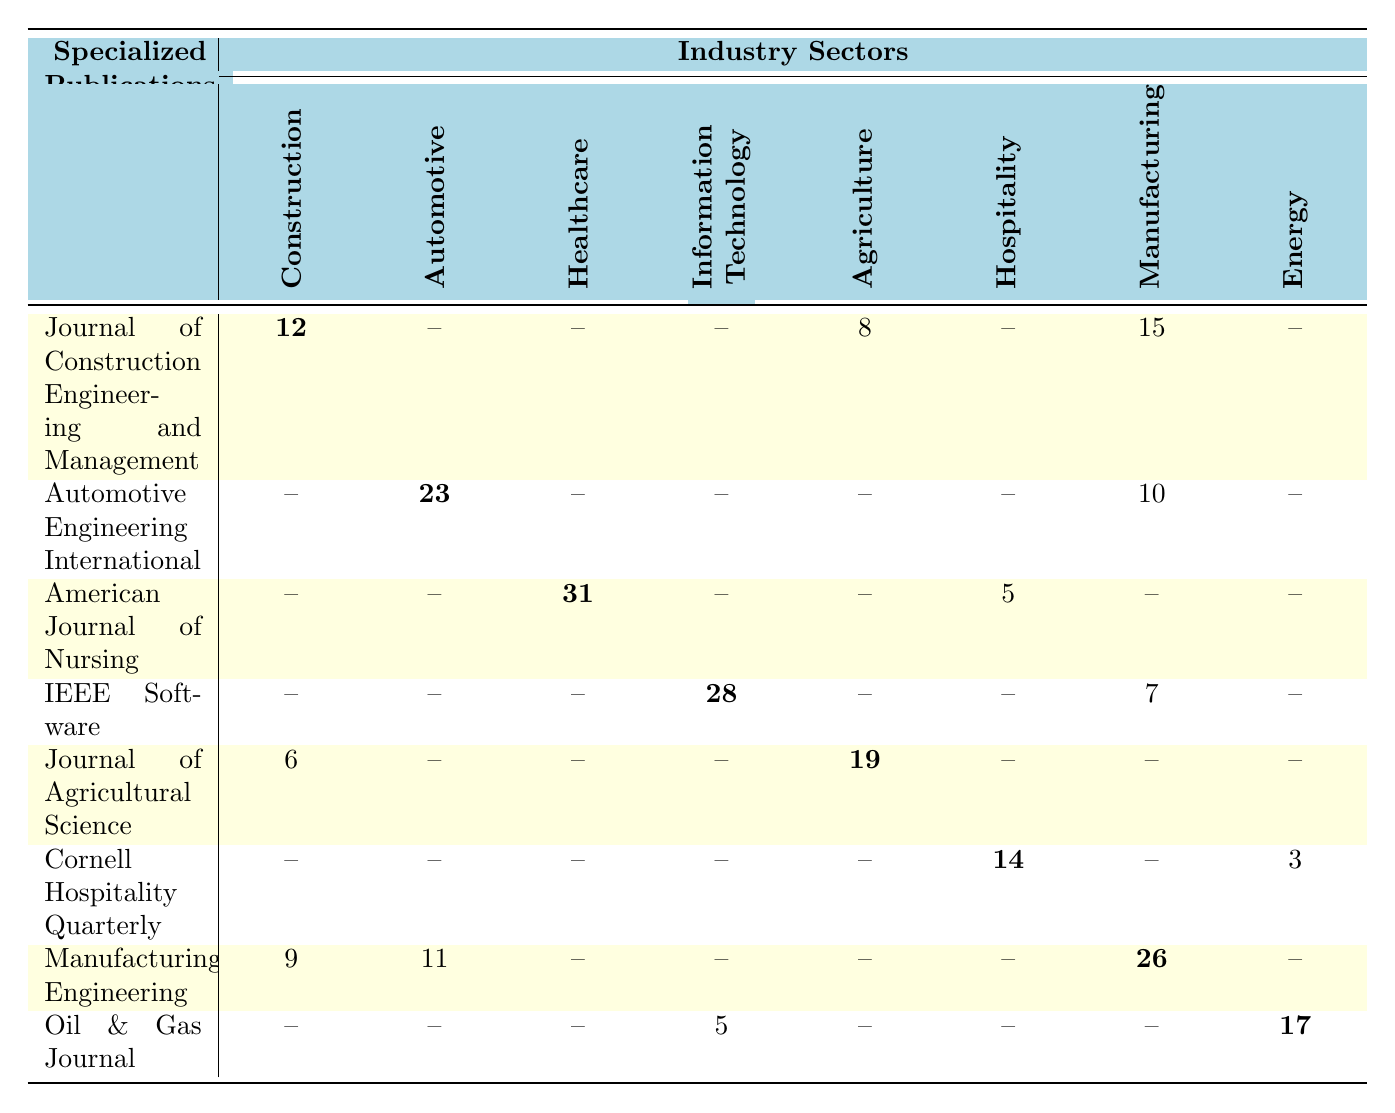What is the total number of interlibrary loan requests for the "American Journal of Nursing"? The table shows that the "American Journal of Nursing" has 31 requests from the Healthcare sector and 5 requests from the Hospitality sector. To find the total, we sum these two values: 31 + 5 = 36.
Answer: 36 Which specialized publication received the highest number of interlibrary loan requests? From the table, the highest number of requests is for the "American Journal of Nursing" with 31 requests in the Healthcare sector.
Answer: American Journal of Nursing How many loan requests were made for publications in the Agriculture sector? Looking at the table, the requests for the Agriculture sector sum up to 8 from the "Journal of Construction Engineering and Management" and 19 from the "Journal of Agricultural Science," totaling 27.
Answer: 27 What is the average number of loan requests for the "Journal of Construction Engineering and Management" across all industry sectors? The requests for "Journal of Construction Engineering and Management" are 12 (Construction), 8 (Agriculture), and 15 (Manufacturing), which totals 35. There are three instances, so the average is 35 / 3 = 11.67.
Answer: 11.67 Did the "Oil & Gas Journal" receive more requests than the "Automotive Engineering International"? The "Oil & Gas Journal" received 17 requests while the "Automotive Engineering International" received 23 requests. Since 17 is less than 23, the statement is false.
Answer: No How many loan requests were made for publications in the Manufacturing sector compared to the Healthcare sector? The Manufacturing sector has a total of 26 requests from "Manufacturing Engineering" and 10 from "Automotive Engineering International," totaling 36. The Healthcare sector has 31 requests from "American Journal of Nursing" and 5 from "Cornell Hospitality Quarterly," totaling 36. They are equal.
Answer: Equal What is the total number of loan requests made for the publications in the Energy sector? The requests for the Energy sector come from the "Oil & Gas Journal," which has 17 requests, and there are no other loan requests listed for Energy, making the total 17.
Answer: 17 Which industry sector has the least interlibrary loan requests for the "Journal of Agricultural Science"? The "Journal of Agricultural Science" received no requests from the Automotive, Healthcare, Information Technology, Hospitality, and Manufacturing sectors. Therefore, it has 0 requests from these sectors; the least requests it received were from the Automotive sector.
Answer: Automotive How many total loan requests were made across all publications for the Hospitality sector? In the Hospitality sector, the requests are 5 from the "American Journal of Nursing," 14 from the "Cornell Hospitality Quarterly," which sums to 19.
Answer: 19 What is the difference in loan requests between "Manufacturing Engineering" and "IEEE Software"? "Manufacturing Engineering" received 26 requests while "IEEE Software" received 28 requests. The difference is 28 - 26 = 2.
Answer: 2 